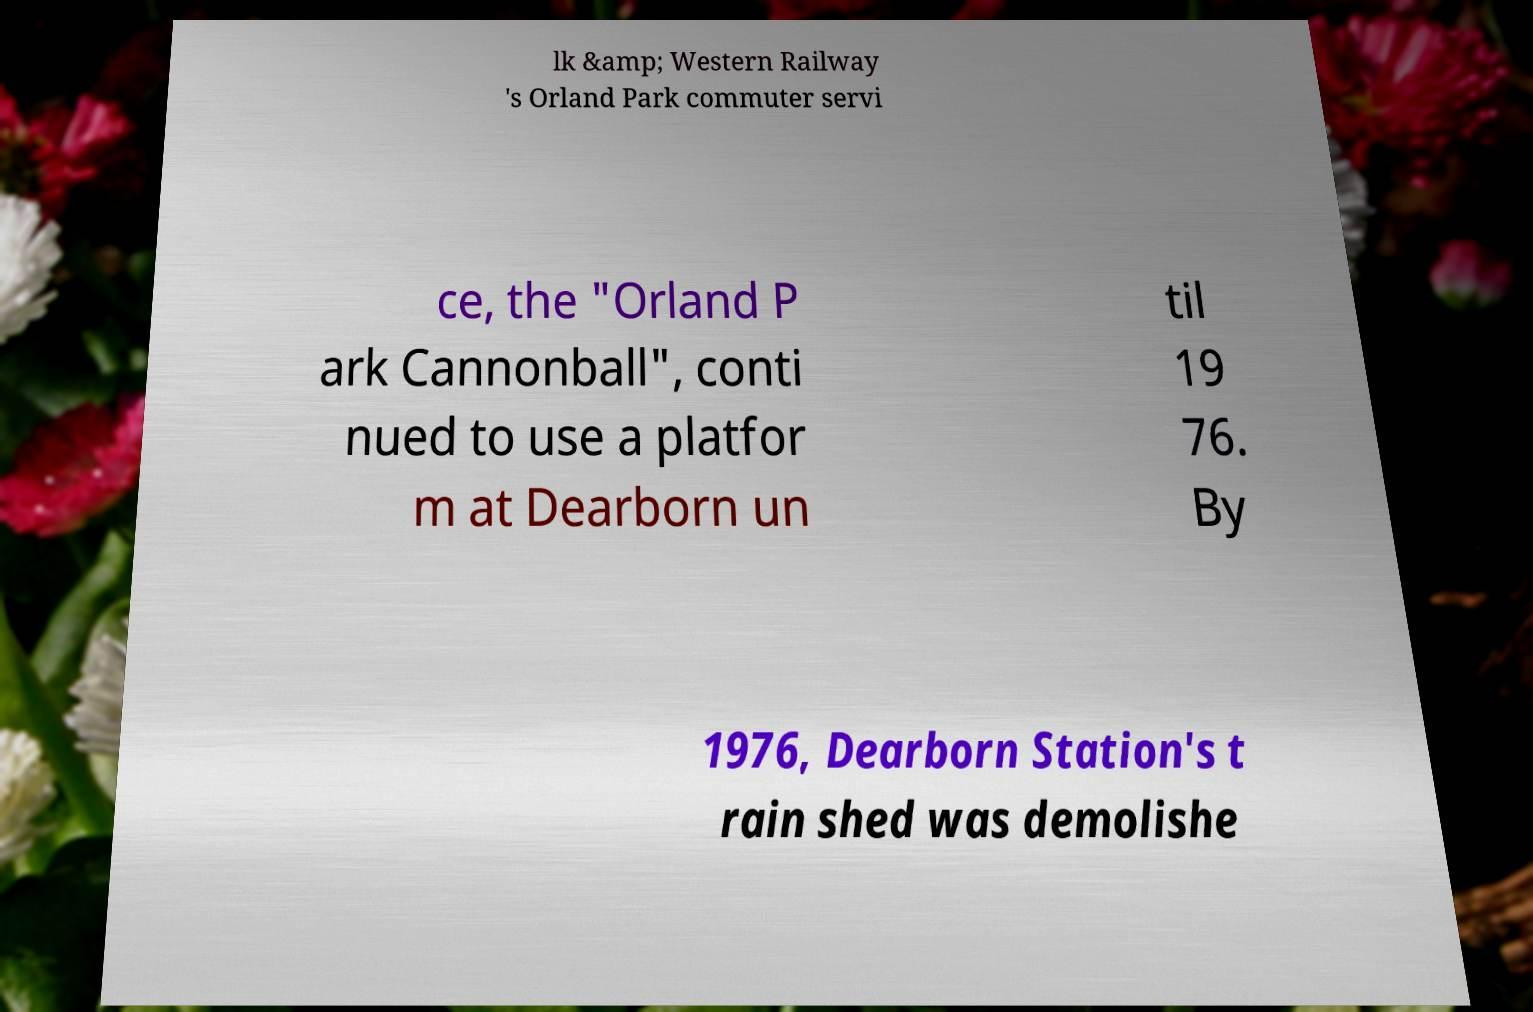Could you extract and type out the text from this image? lk &amp; Western Railway 's Orland Park commuter servi ce, the "Orland P ark Cannonball", conti nued to use a platfor m at Dearborn un til 19 76. By 1976, Dearborn Station's t rain shed was demolishe 